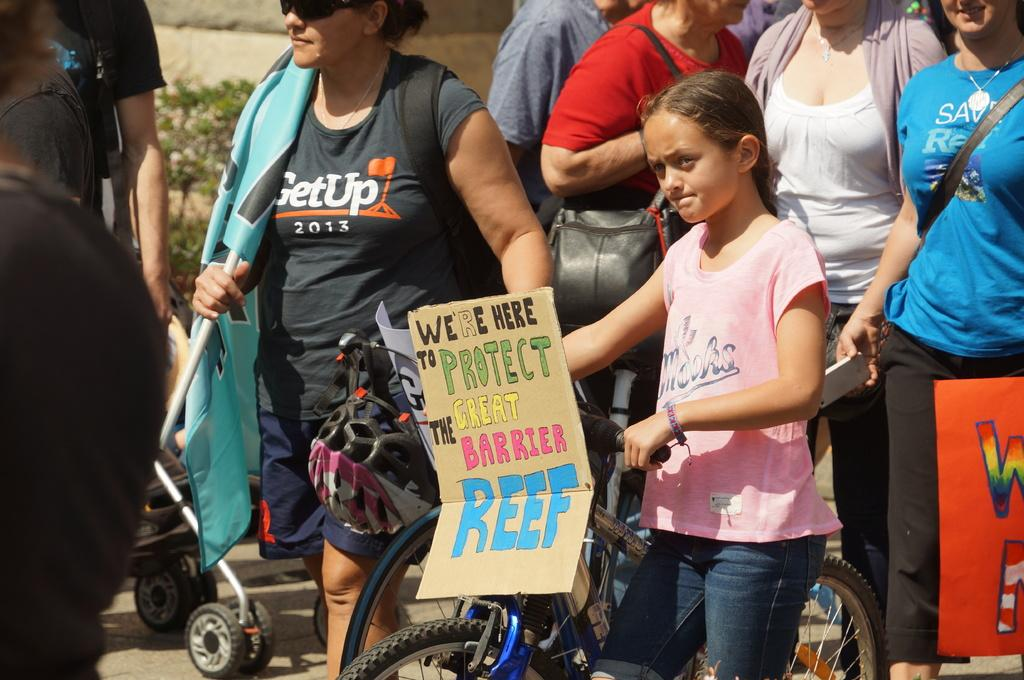What can be seen in the foreground of the picture? In the foreground of the picture, there are people, a bicycle, and a cart. What are some of the people holding in the picture? Some people are holding placards and a flag. What can be seen in the background of the picture? In the background, there is a plant and a wall. What type of mist can be seen surrounding the achiever in the image? There is no achiever or mist present in the image. What type of crown is the queen wearing in the image? There is no queen or crown present in the image. 